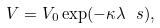Convert formula to latex. <formula><loc_0><loc_0><loc_500><loc_500>V = V _ { 0 } \exp ( - \kappa \lambda \ s ) ,</formula> 